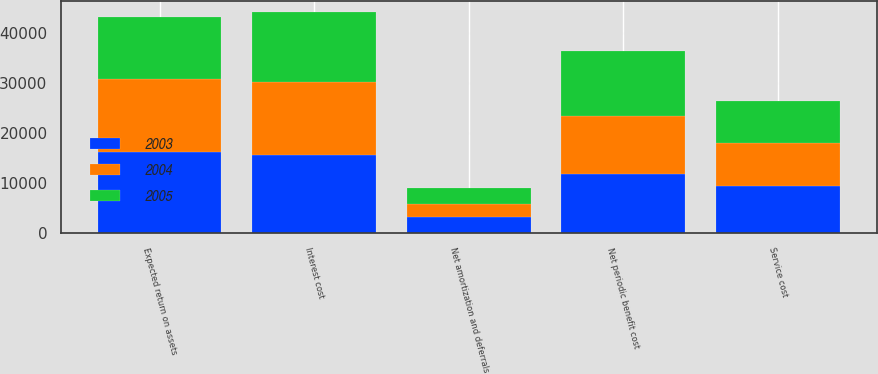Convert chart. <chart><loc_0><loc_0><loc_500><loc_500><stacked_bar_chart><ecel><fcel>Service cost<fcel>Interest cost<fcel>Expected return on assets<fcel>Net amortization and deferrals<fcel>Net periodic benefit cost<nl><fcel>2003<fcel>9384<fcel>15526<fcel>16275<fcel>3136<fcel>11771<nl><fcel>2004<fcel>8632<fcel>14630<fcel>14489<fcel>2750<fcel>11523<nl><fcel>2005<fcel>8263<fcel>14026<fcel>12350<fcel>3060<fcel>12999<nl></chart> 